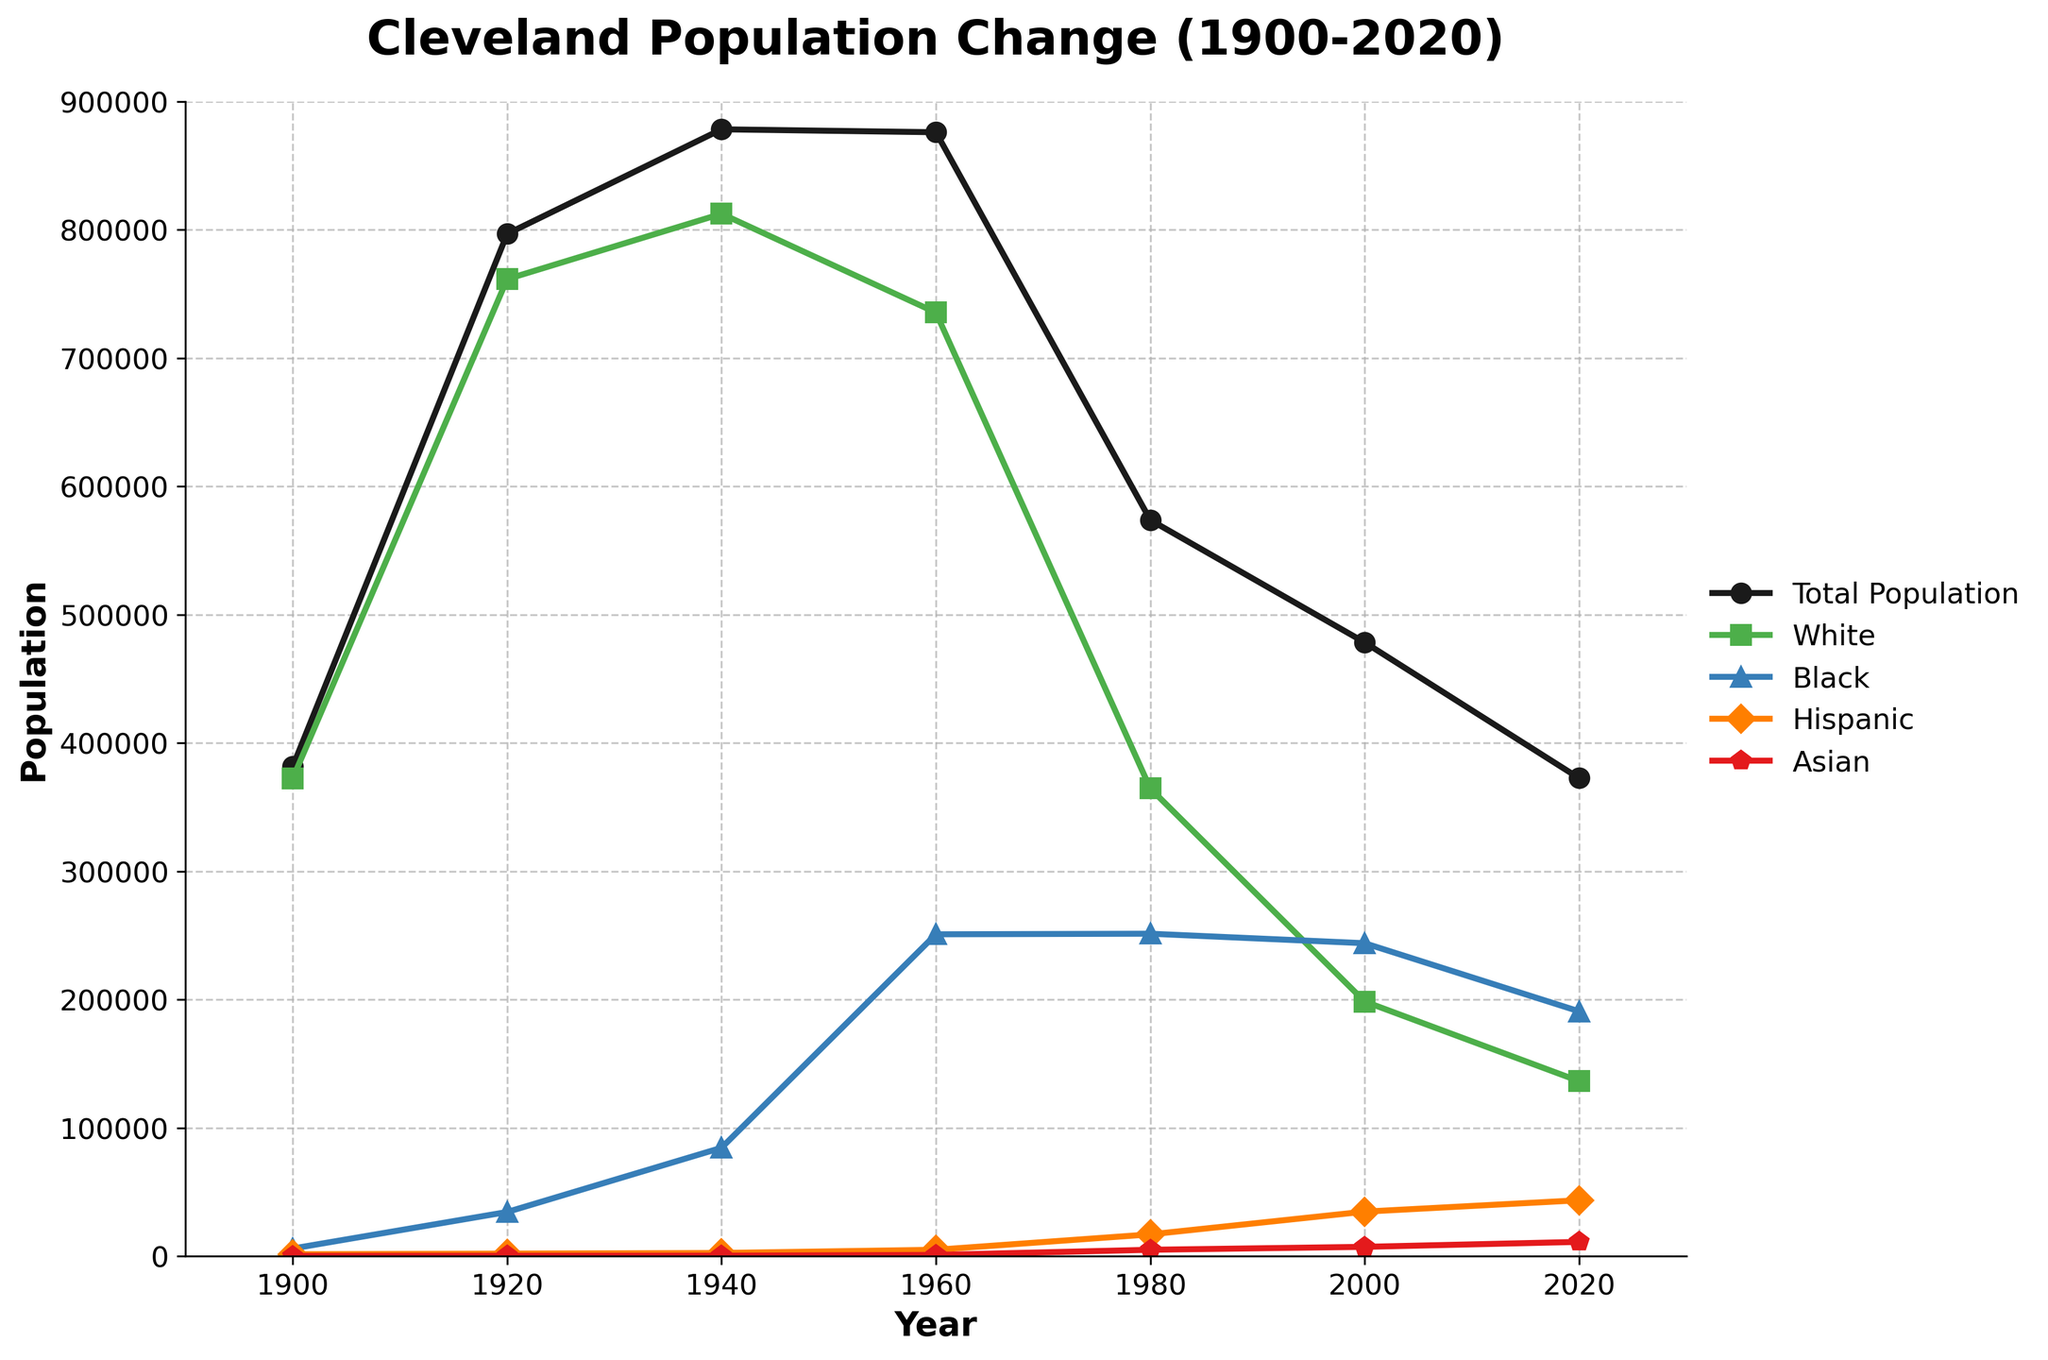How has the total population of Cleveland changed from 1900 to 2020? The total population peaked around 1960 and then declined steadily. From the chart, the population was around 381,768 in 1900, grew to 878,336 by 1940, reached 876,050 in 1960, and then declined to 372,624 by 2020.
Answer: Declined Which ethnic group experienced the most significant increase in population from 1900 to 2020? Comparing the population numbers for each ethnic group over the years, the Hispanic population increased from 1,500 in 1900 to 43,592 in 2020, showing a significant growth compared to other groups.
Answer: Hispanic During which decade did the Black population of Cleveland see the most prominent increase, based on the visual trend? From the visual trend, the Black population increased significantly between 1940 and 1960, from 84,504 to 250,899.
Answer: 1940-1960 Compare the population trends of the White and Black groups from 1960 to 2020. From 1960 to 2020, the White population consistently declined from 735,488 to 136,444, while the Black population showed a peak around 1980 (251,347) but still maintained relatively high numbers, resulting in a smaller decrease overall (to 190,864 in 2020).
Answer: White declined more Calculate the total population change from 1960 to 2020. The total population in 1960 was 876,050 and in 2020 was 372,624. The change is 876,050 - 372,624 = 503,426.
Answer: 503,426 By how much did the Asian population increase from 1900 to 2020? The Asian population was 200 in 1900 and increased to 11,153 in 2020. The increase is 11,153 - 200 = 10,953.
Answer: 10,953 Which group had the lowest population in 1920, and what was its value? The Asian population was the lowest in 1920 with a population of 300.
Answer: Asian, 300 What visual trend can be observed about the total population from 1960 onwards? From the plot, the total population shows a steady decline from 1960 onwards.
Answer: Decline 